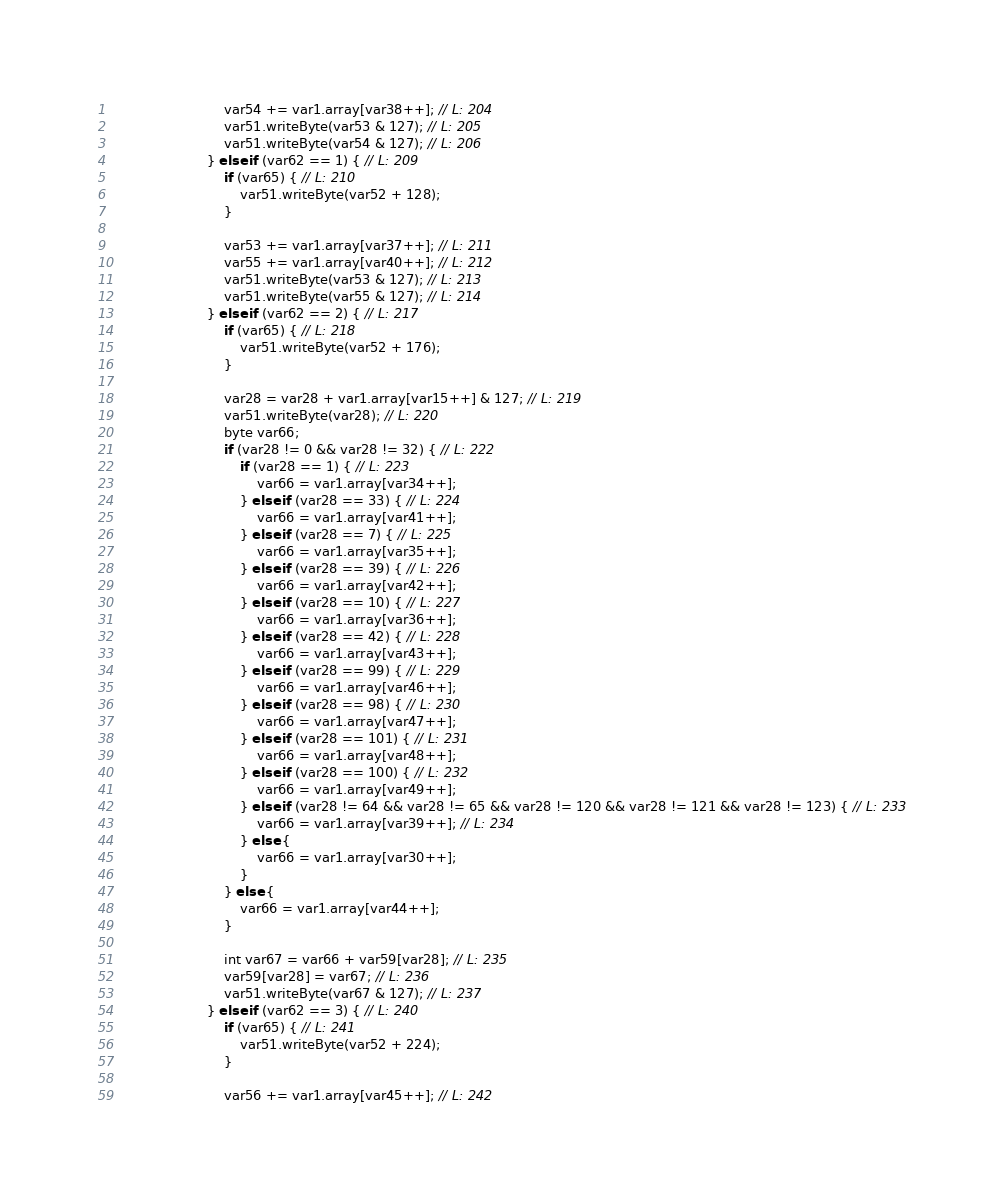<code> <loc_0><loc_0><loc_500><loc_500><_Java_>							var54 += var1.array[var38++]; // L: 204
							var51.writeByte(var53 & 127); // L: 205
							var51.writeByte(var54 & 127); // L: 206
						} else if (var62 == 1) { // L: 209
							if (var65) { // L: 210
								var51.writeByte(var52 + 128);
							}

							var53 += var1.array[var37++]; // L: 211
							var55 += var1.array[var40++]; // L: 212
							var51.writeByte(var53 & 127); // L: 213
							var51.writeByte(var55 & 127); // L: 214
						} else if (var62 == 2) { // L: 217
							if (var65) { // L: 218
								var51.writeByte(var52 + 176);
							}

							var28 = var28 + var1.array[var15++] & 127; // L: 219
							var51.writeByte(var28); // L: 220
							byte var66;
							if (var28 != 0 && var28 != 32) { // L: 222
								if (var28 == 1) { // L: 223
									var66 = var1.array[var34++];
								} else if (var28 == 33) { // L: 224
									var66 = var1.array[var41++];
								} else if (var28 == 7) { // L: 225
									var66 = var1.array[var35++];
								} else if (var28 == 39) { // L: 226
									var66 = var1.array[var42++];
								} else if (var28 == 10) { // L: 227
									var66 = var1.array[var36++];
								} else if (var28 == 42) { // L: 228
									var66 = var1.array[var43++];
								} else if (var28 == 99) { // L: 229
									var66 = var1.array[var46++];
								} else if (var28 == 98) { // L: 230
									var66 = var1.array[var47++];
								} else if (var28 == 101) { // L: 231
									var66 = var1.array[var48++];
								} else if (var28 == 100) { // L: 232
									var66 = var1.array[var49++];
								} else if (var28 != 64 && var28 != 65 && var28 != 120 && var28 != 121 && var28 != 123) { // L: 233
									var66 = var1.array[var39++]; // L: 234
								} else {
									var66 = var1.array[var30++];
								}
							} else {
								var66 = var1.array[var44++];
							}

							int var67 = var66 + var59[var28]; // L: 235
							var59[var28] = var67; // L: 236
							var51.writeByte(var67 & 127); // L: 237
						} else if (var62 == 3) { // L: 240
							if (var65) { // L: 241
								var51.writeByte(var52 + 224);
							}

							var56 += var1.array[var45++]; // L: 242</code> 